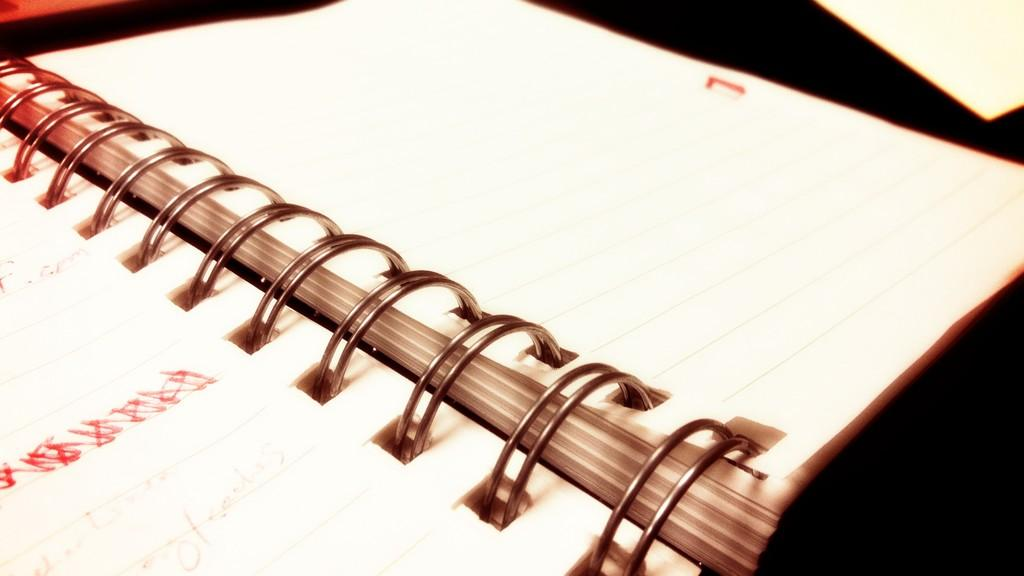What object is present in the image? There is a book in the image. What is the book placed on? The book is on a black color surface. What type of coat is the book wearing in the image? The book is not a living being and therefore cannot wear a coat. Can you tell me the credit score of the book in the image? The book is an inanimate object and does not have a credit score. 